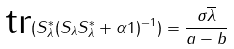<formula> <loc_0><loc_0><loc_500><loc_500>\text {tr} ( S _ { \lambda } ^ { * } ( S _ { \lambda } S _ { \lambda } ^ { * } + \alpha 1 ) ^ { - 1 } ) = \frac { \sigma \overline { \lambda } } { a - b }</formula> 